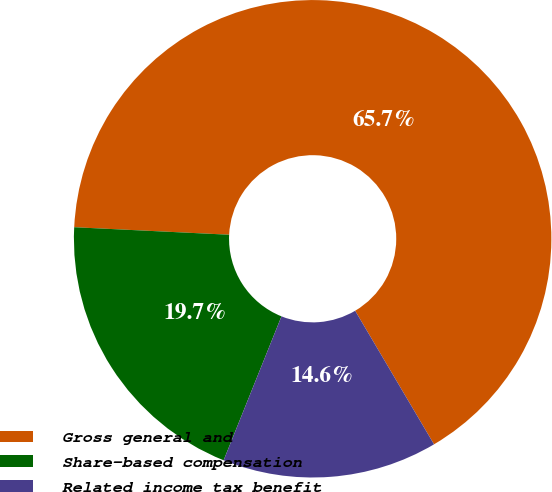Convert chart to OTSL. <chart><loc_0><loc_0><loc_500><loc_500><pie_chart><fcel>Gross general and<fcel>Share-based compensation<fcel>Related income tax benefit<nl><fcel>65.74%<fcel>19.69%<fcel>14.57%<nl></chart> 